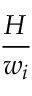<formula> <loc_0><loc_0><loc_500><loc_500>\frac { H } { w _ { i } }</formula> 